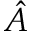Convert formula to latex. <formula><loc_0><loc_0><loc_500><loc_500>\hat { A }</formula> 